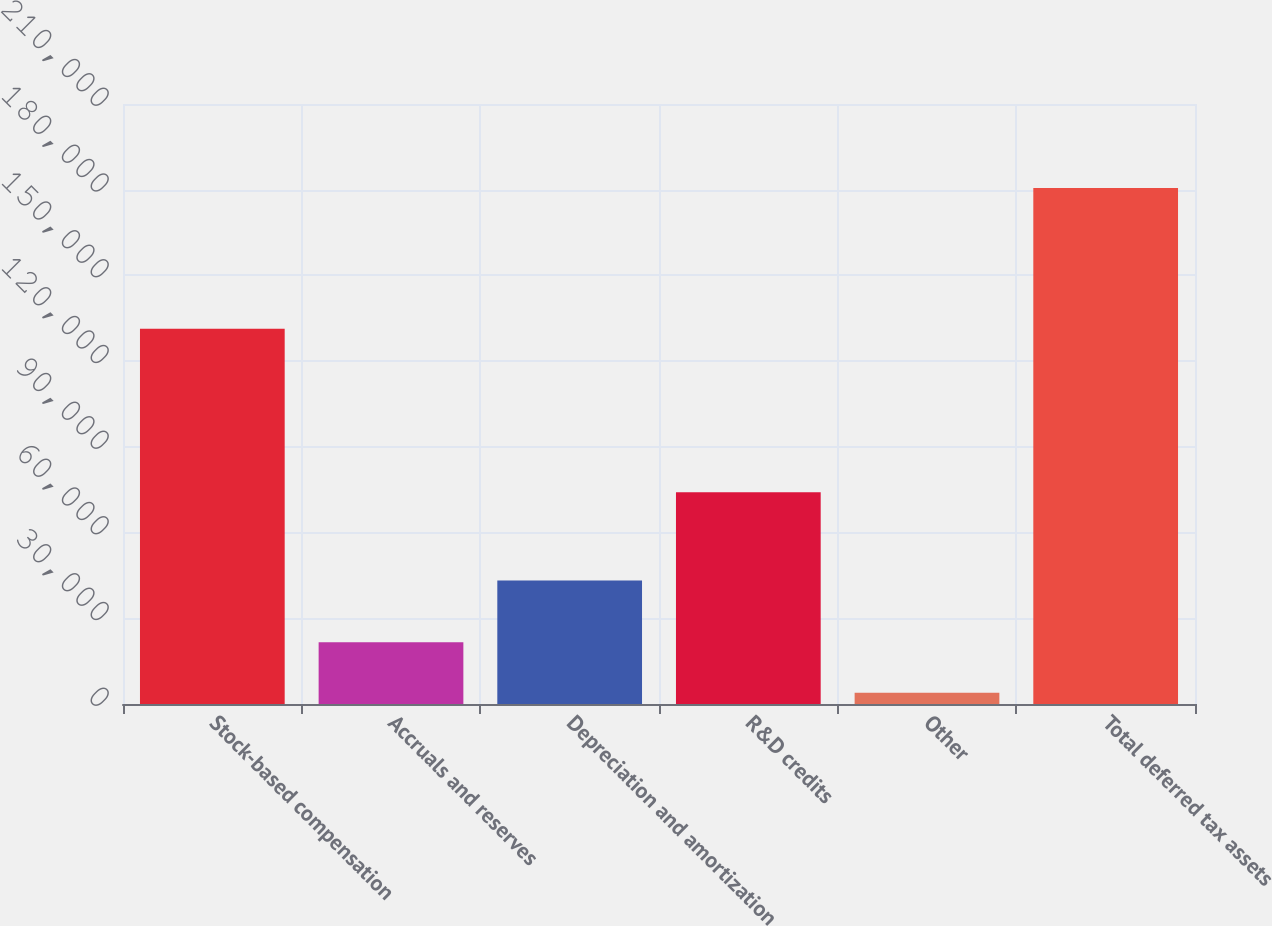Convert chart to OTSL. <chart><loc_0><loc_0><loc_500><loc_500><bar_chart><fcel>Stock-based compensation<fcel>Accruals and reserves<fcel>Depreciation and amortization<fcel>R&D credits<fcel>Other<fcel>Total deferred tax assets<nl><fcel>131339<fcel>21639.3<fcel>43204<fcel>74091<fcel>3980<fcel>180573<nl></chart> 